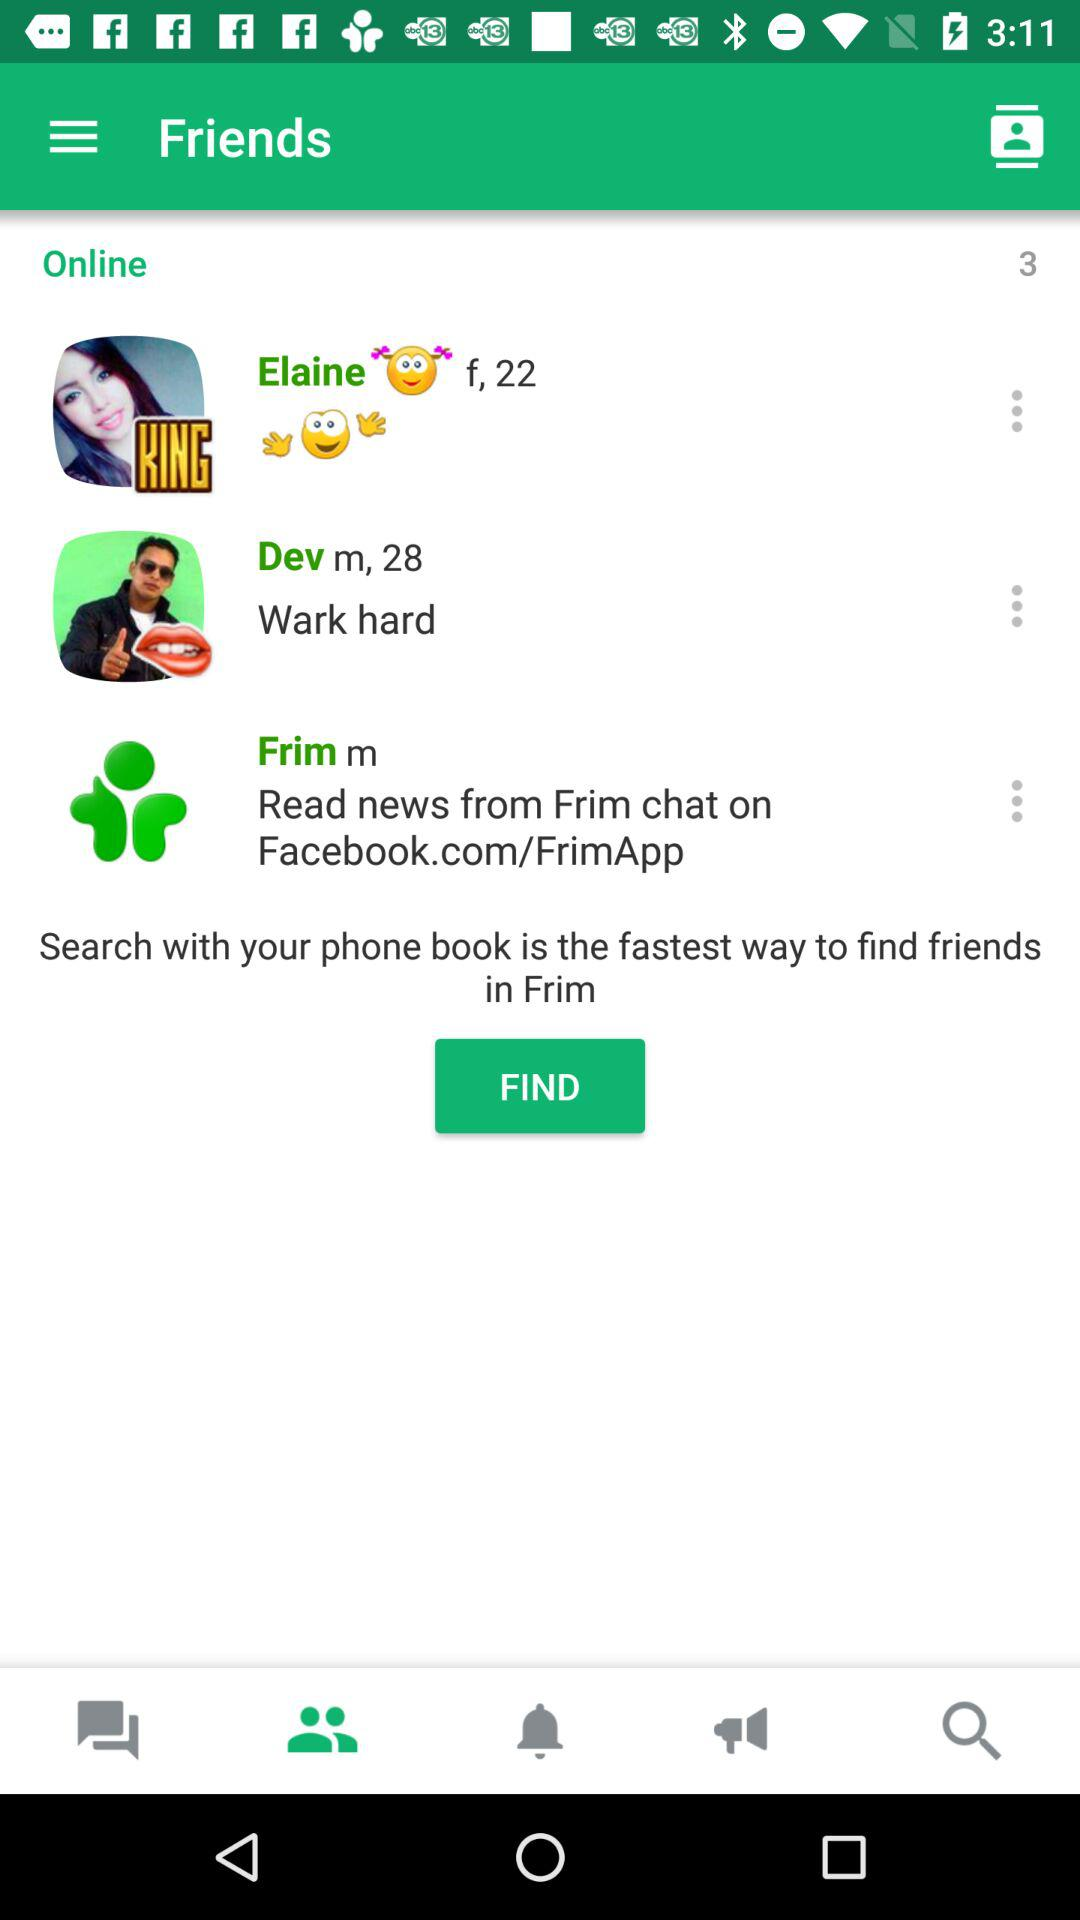How many friends are online? There are 3 friends who are online. 